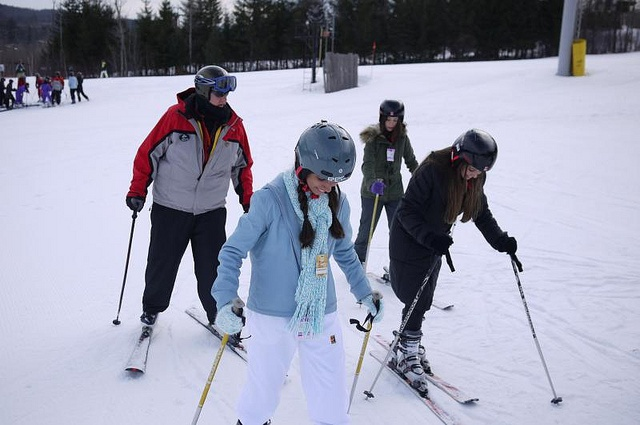Describe the objects in this image and their specific colors. I can see people in darkgray, gray, and lavender tones, people in darkgray, black, gray, and maroon tones, people in darkgray, black, gray, and lavender tones, people in darkgray, black, gray, and lavender tones, and skis in darkgray, lavender, and gray tones in this image. 